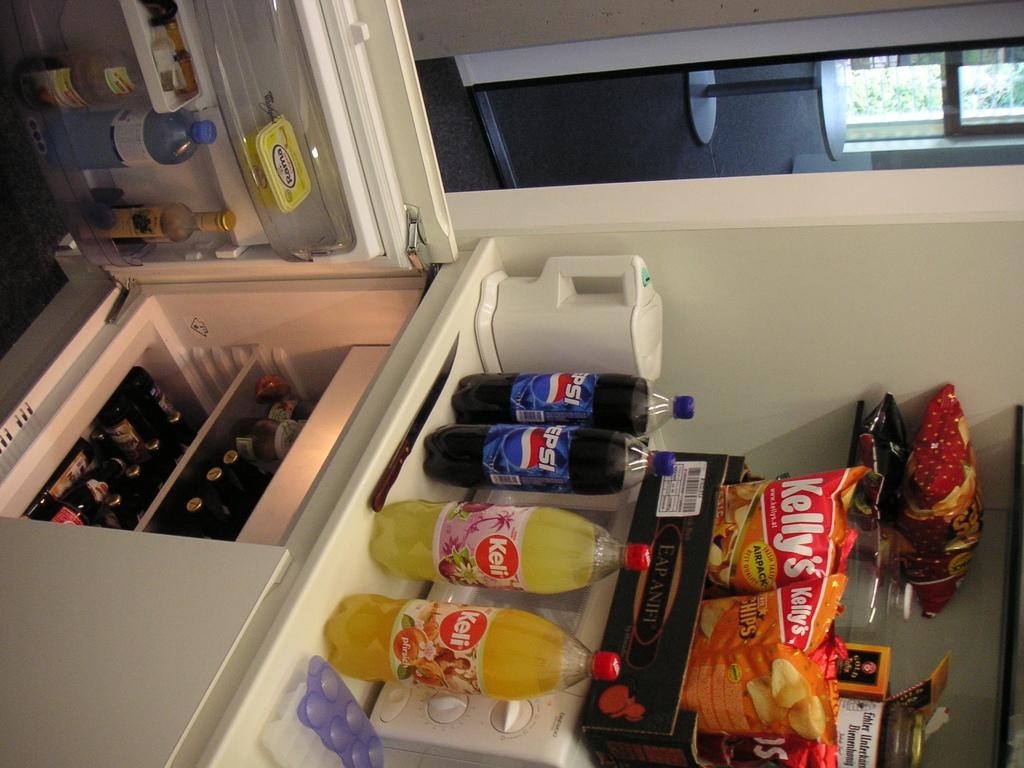<image>
Present a compact description of the photo's key features. The contents of a shelf are shown that contain Pepsi drinks, Keli drinks, and Kelly's brand potato chips. 